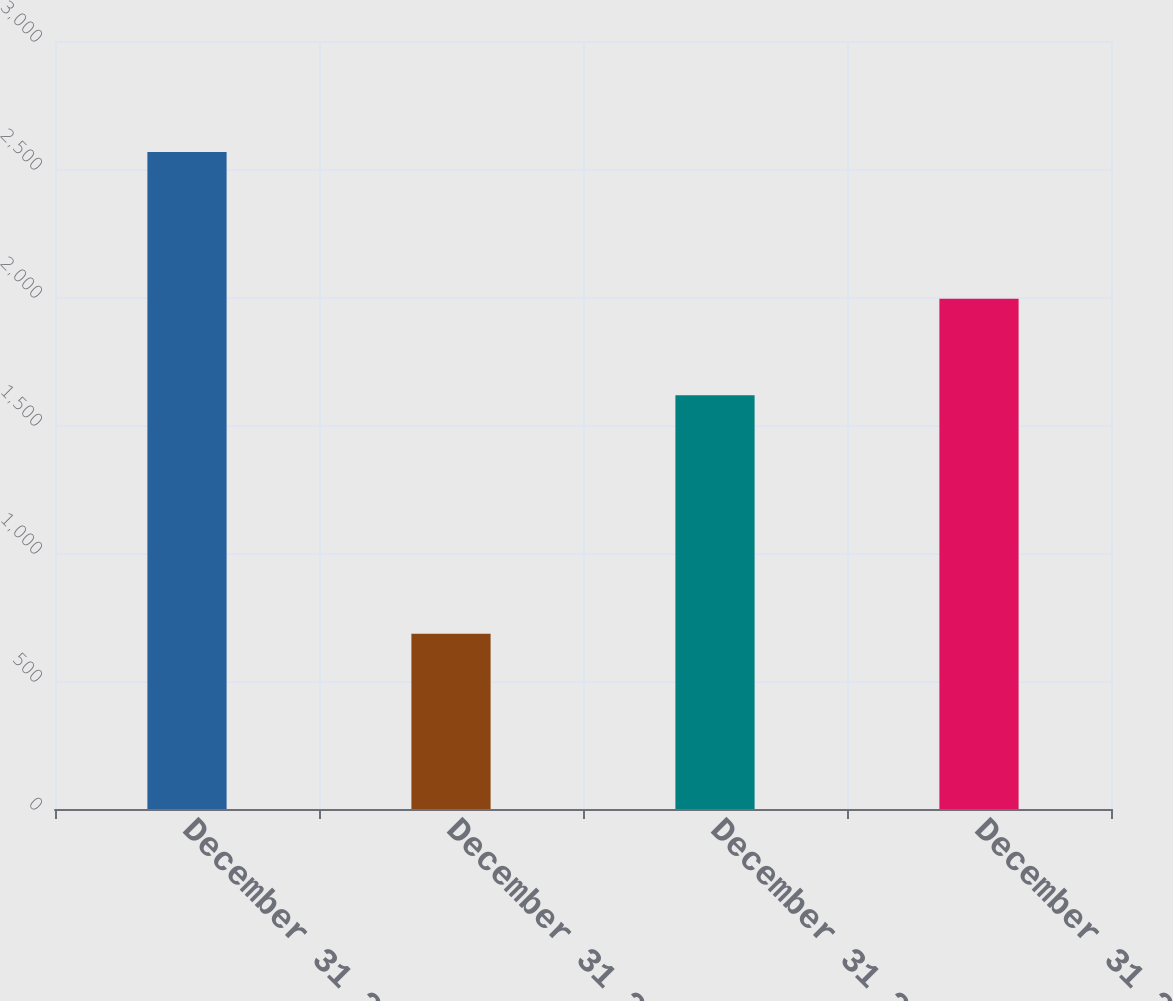<chart> <loc_0><loc_0><loc_500><loc_500><bar_chart><fcel>December 31 2007<fcel>December 31 2008<fcel>December 31 2009<fcel>December 31 2010<nl><fcel>2566<fcel>685<fcel>1616<fcel>1993<nl></chart> 